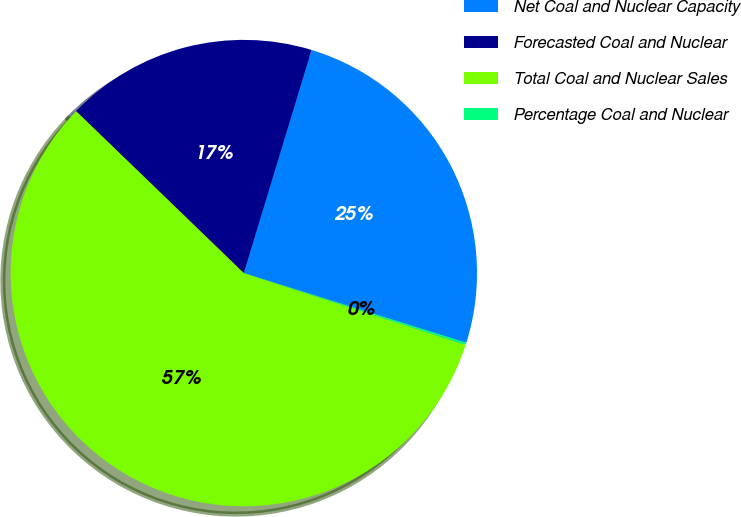Convert chart. <chart><loc_0><loc_0><loc_500><loc_500><pie_chart><fcel>Net Coal and Nuclear Capacity<fcel>Forecasted Coal and Nuclear<fcel>Total Coal and Nuclear Sales<fcel>Percentage Coal and Nuclear<nl><fcel>25.14%<fcel>17.47%<fcel>57.24%<fcel>0.15%<nl></chart> 